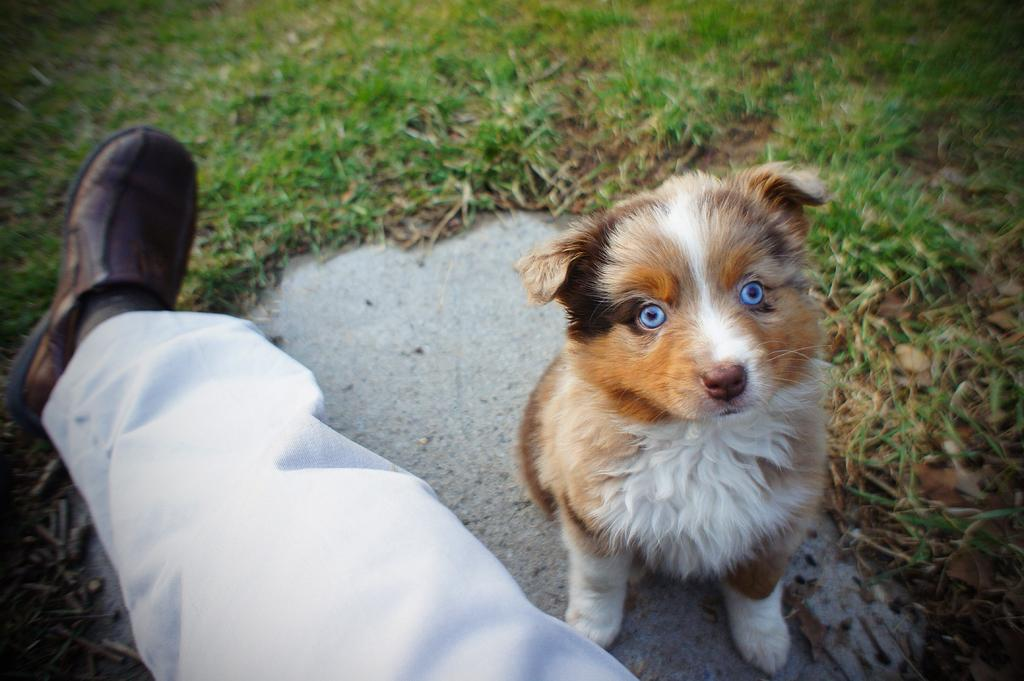What part of a person can be seen in the image? There is a leg of a person in the image. What animal is present in the image? There is a dog in the image. What type of vegetation is visible in the image? There is grass visible in the image. Can you see a pig playing in the stream in the image? There is no pig or stream present in the image. 